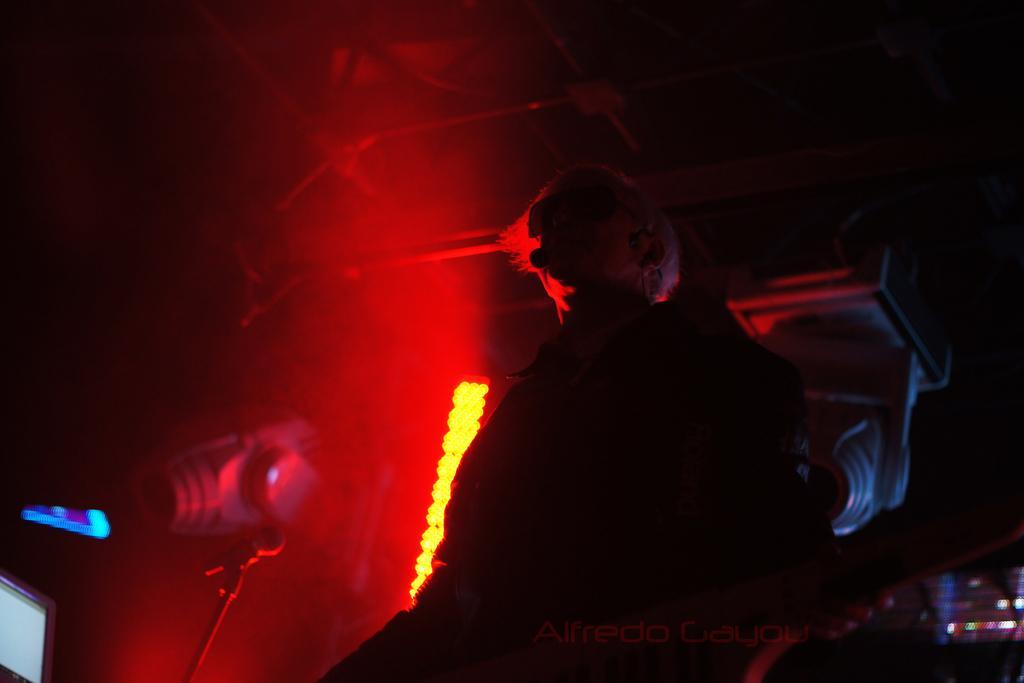Could you give a brief overview of what you see in this image? In the center of the image we can see a person. On the left there is a mic. In the background there is a light. 